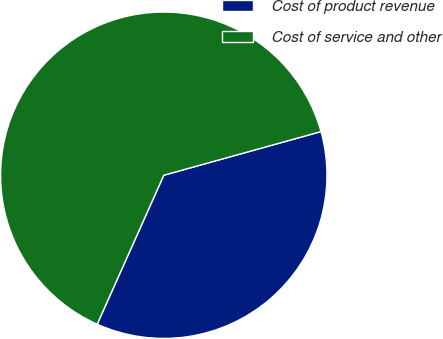Convert chart. <chart><loc_0><loc_0><loc_500><loc_500><pie_chart><fcel>Cost of product revenue<fcel>Cost of service and other<nl><fcel>36.0%<fcel>64.0%<nl></chart> 